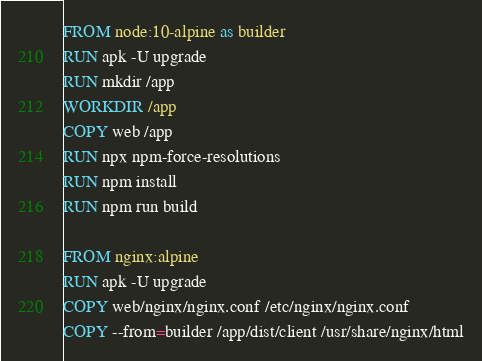<code> <loc_0><loc_0><loc_500><loc_500><_Dockerfile_>FROM node:10-alpine as builder
RUN apk -U upgrade
RUN mkdir /app
WORKDIR /app
COPY web /app
RUN npx npm-force-resolutions
RUN npm install
RUN npm run build

FROM nginx:alpine
RUN apk -U upgrade
COPY web/nginx/nginx.conf /etc/nginx/nginx.conf
COPY --from=builder /app/dist/client /usr/share/nginx/html
</code> 